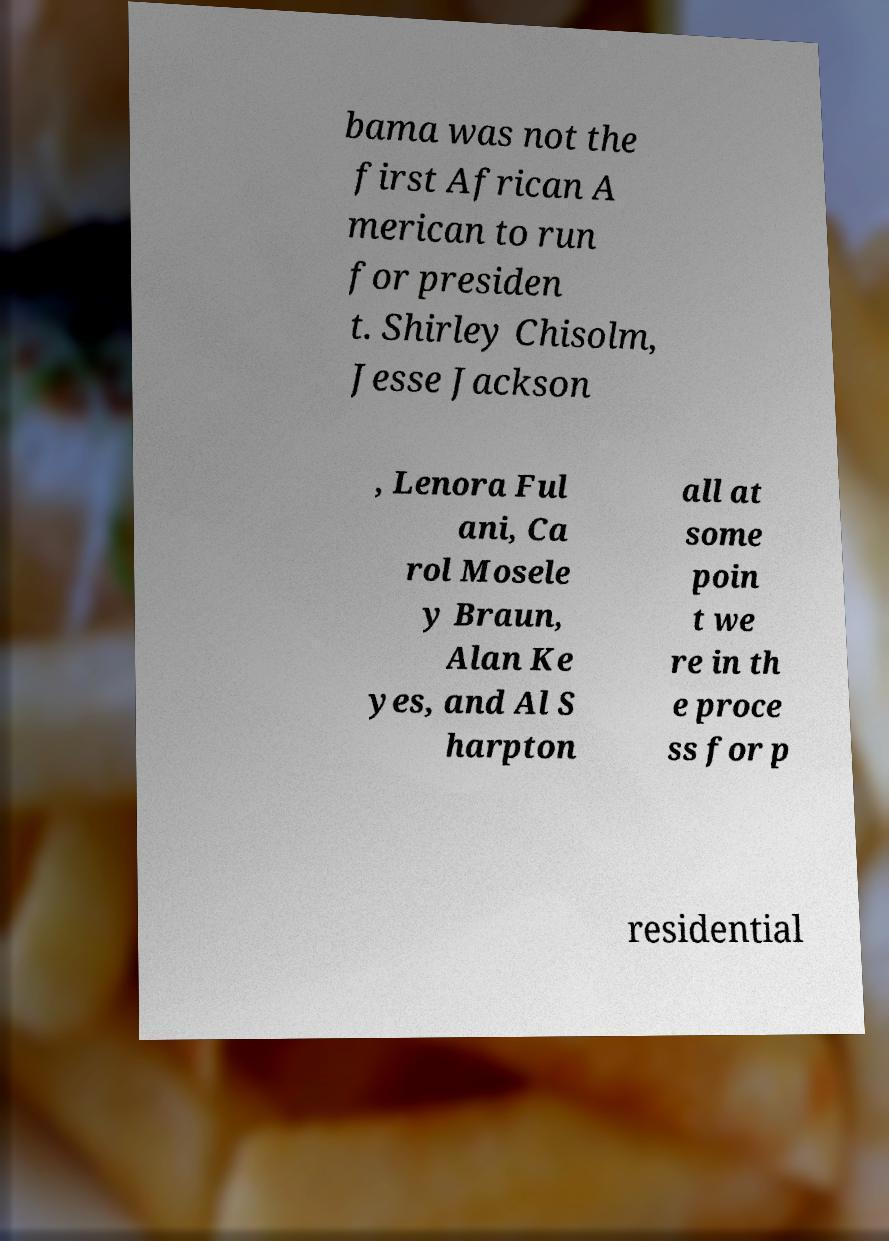Please read and relay the text visible in this image. What does it say? bama was not the first African A merican to run for presiden t. Shirley Chisolm, Jesse Jackson , Lenora Ful ani, Ca rol Mosele y Braun, Alan Ke yes, and Al S harpton all at some poin t we re in th e proce ss for p residential 